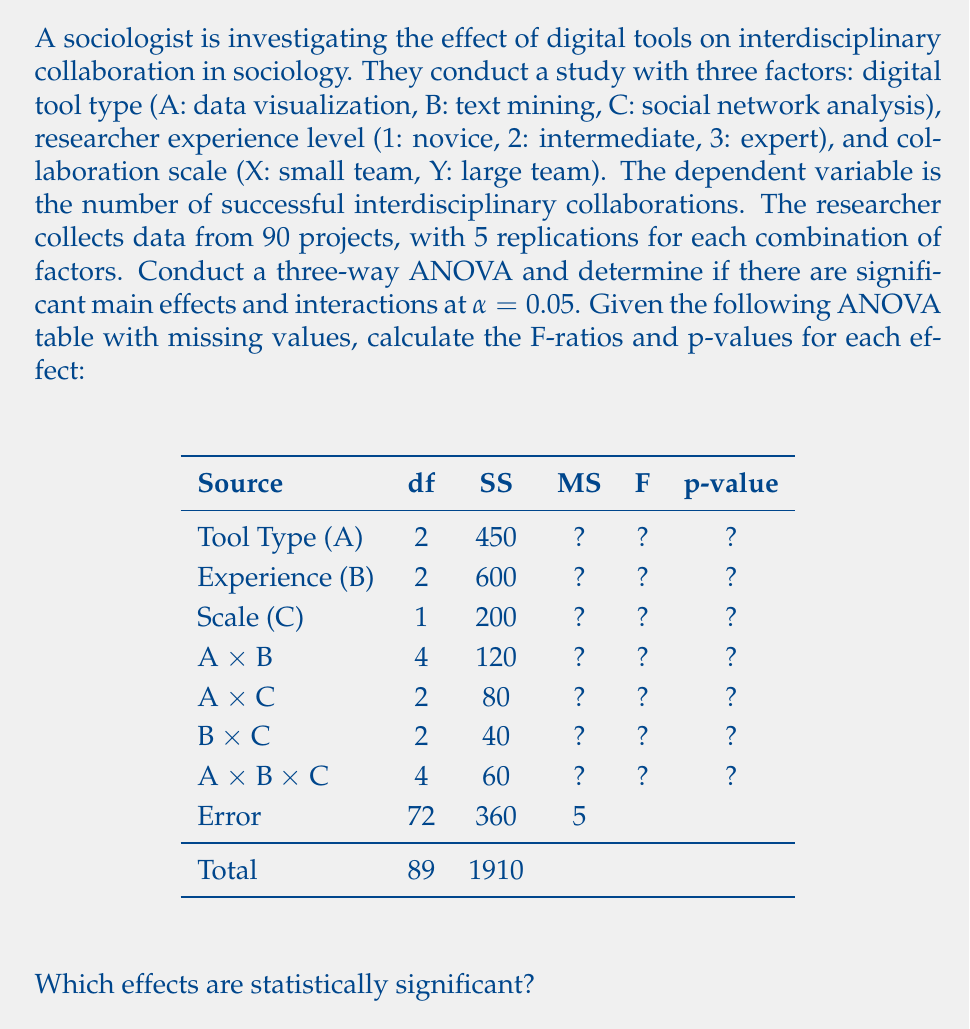Help me with this question. To solve this problem, we need to calculate the Mean Square (MS) for each effect, then compute the F-ratios and p-values. We'll use the Error MS as the denominator for all F-ratios.

1. Calculate MS for each effect:
   MS = SS / df

   Tool Type (A): $MS_A = 450 / 2 = 225$
   Experience (B): $MS_B = 600 / 2 = 300$
   Scale (C): $MS_C = 200 / 1 = 200$
   A × B: $MS_{AB} = 120 / 4 = 30$
   A × C: $MS_{AC} = 80 / 2 = 40$
   B × C: $MS_{BC} = 40 / 2 = 20$
   A × B × C: $MS_{ABC} = 60 / 4 = 15$
   Error: $MS_E = 360 / 72 = 5$ (given)

2. Calculate F-ratios:
   F = MS_effect / MS_error

   Tool Type (A): $F_A = 225 / 5 = 45$
   Experience (B): $F_B = 300 / 5 = 60$
   Scale (C): $F_C = 200 / 5 = 40$
   A × B: $F_{AB} = 30 / 5 = 6$
   A × C: $F_{AC} = 40 / 5 = 8$
   B × C: $F_{BC} = 20 / 5 = 4$
   A × B × C: $F_{ABC} = 15 / 5 = 3$

3. Calculate p-values:
   Use the F-distribution with the corresponding degrees of freedom for each effect and the error df (72).

   Tool Type (A): $p_A = P(F_{2,72} > 45) < 0.001$
   Experience (B): $p_B = P(F_{2,72} > 60) < 0.001$
   Scale (C): $p_C = P(F_{1,72} > 40) < 0.001$
   A × B: $p_{AB} = P(F_{4,72} > 6) < 0.001$
   A × C: $p_{AC} = P(F_{2,72} > 8) < 0.001$
   B × C: $p_{BC} = P(F_{2,72} > 4) \approx 0.022$
   A × B × C: $p_{ABC} = P(F_{4,72} > 3) \approx 0.024$

4. Compare p-values to α = 0.05:
   All effects have p-values less than 0.05, indicating that they are all statistically significant.
Answer: All effects (main effects and interactions) are statistically significant at α = 0.05. The completed ANOVA table is:

$$
\begin{array}{lcccc}
\text{Source} & \text{df} & \text{SS} & \text{MS} & \text{F} & \text{p-value} \\
\hline
\text{Tool Type (A)} & 2 & 450 & 225 & 45 & <0.001 \\
\text{Experience (B)} & 2 & 600 & 300 & 60 & <0.001 \\
\text{Scale (C)} & 1 & 200 & 200 & 40 & <0.001 \\
\text{A × B} & 4 & 120 & 30 & 6 & <0.001 \\
\text{A × C} & 2 & 80 & 40 & 8 & <0.001 \\
\text{B × C} & 2 & 40 & 20 & 4 & 0.022 \\
\text{A × B × C} & 4 & 60 & 15 & 3 & 0.024 \\
\text{Error} & 72 & 360 & 5 & & \\
\text{Total} & 89 & 1910 & & & \\
\end{array}
$$

This suggests that digital tool type, researcher experience level, and collaboration scale all have significant main effects and interactions on interdisciplinary collaboration in sociology. 